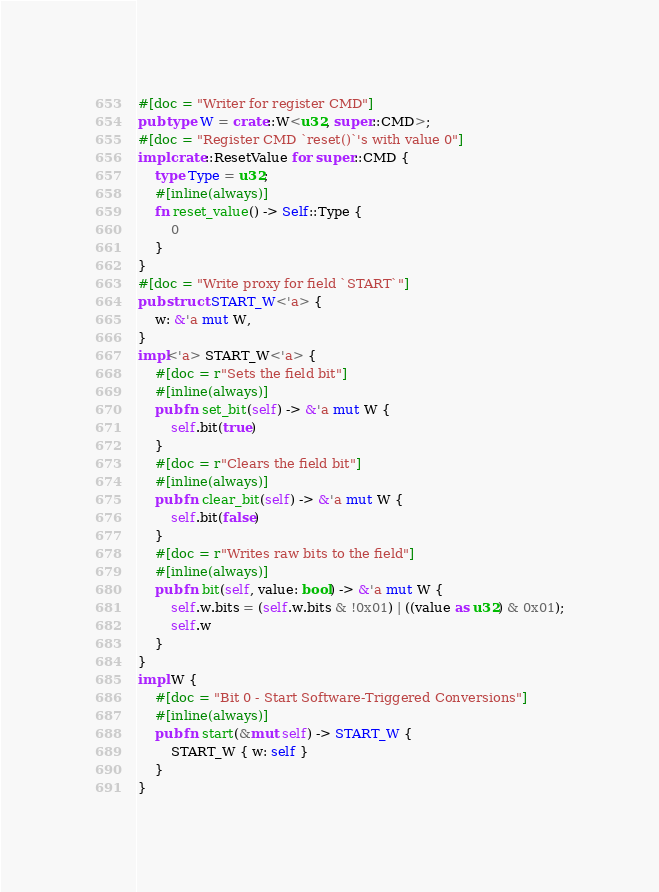Convert code to text. <code><loc_0><loc_0><loc_500><loc_500><_Rust_>#[doc = "Writer for register CMD"]
pub type W = crate::W<u32, super::CMD>;
#[doc = "Register CMD `reset()`'s with value 0"]
impl crate::ResetValue for super::CMD {
    type Type = u32;
    #[inline(always)]
    fn reset_value() -> Self::Type {
        0
    }
}
#[doc = "Write proxy for field `START`"]
pub struct START_W<'a> {
    w: &'a mut W,
}
impl<'a> START_W<'a> {
    #[doc = r"Sets the field bit"]
    #[inline(always)]
    pub fn set_bit(self) -> &'a mut W {
        self.bit(true)
    }
    #[doc = r"Clears the field bit"]
    #[inline(always)]
    pub fn clear_bit(self) -> &'a mut W {
        self.bit(false)
    }
    #[doc = r"Writes raw bits to the field"]
    #[inline(always)]
    pub fn bit(self, value: bool) -> &'a mut W {
        self.w.bits = (self.w.bits & !0x01) | ((value as u32) & 0x01);
        self.w
    }
}
impl W {
    #[doc = "Bit 0 - Start Software-Triggered Conversions"]
    #[inline(always)]
    pub fn start(&mut self) -> START_W {
        START_W { w: self }
    }
}
</code> 